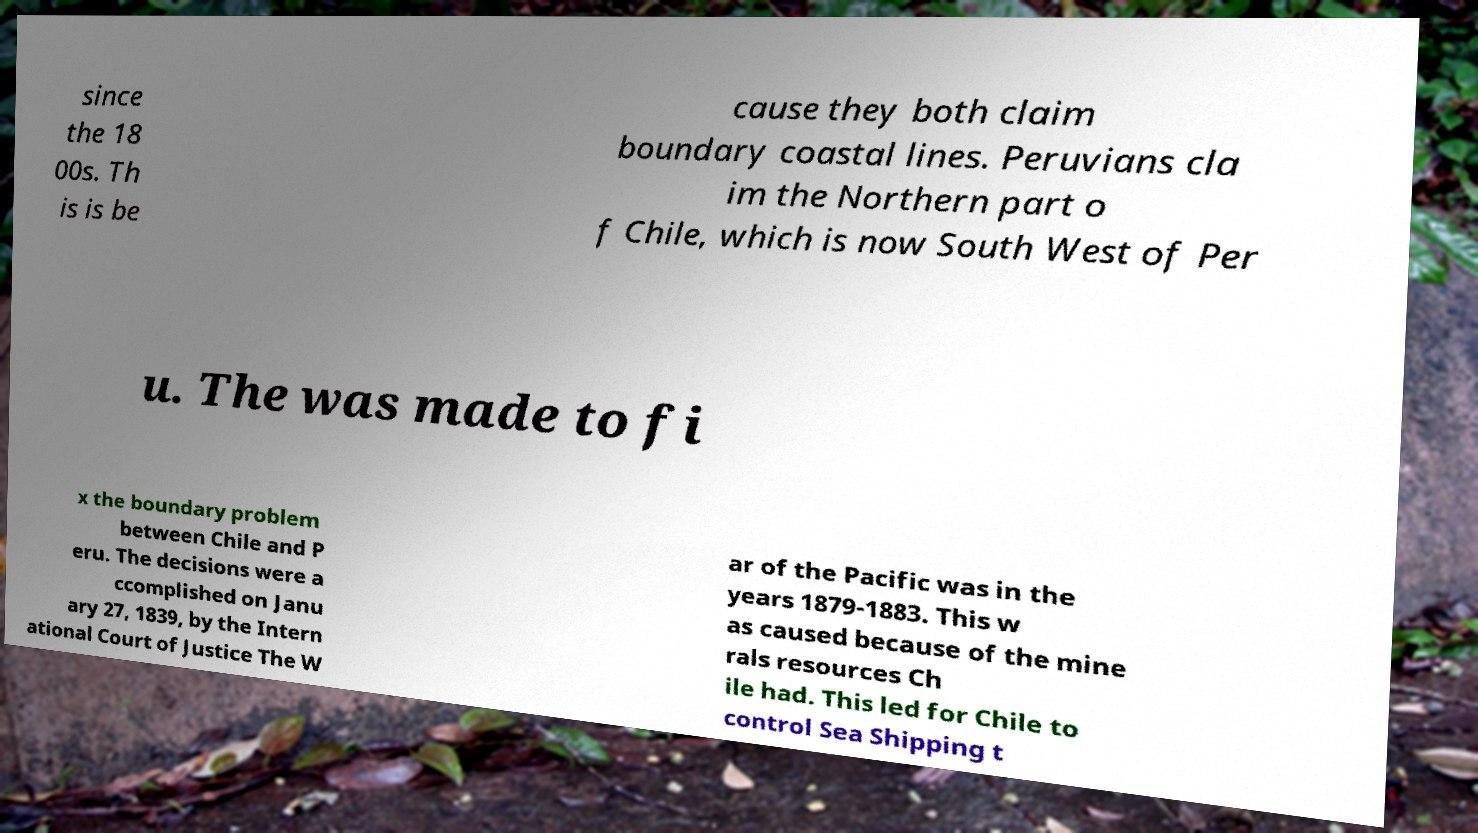For documentation purposes, I need the text within this image transcribed. Could you provide that? since the 18 00s. Th is is be cause they both claim boundary coastal lines. Peruvians cla im the Northern part o f Chile, which is now South West of Per u. The was made to fi x the boundary problem between Chile and P eru. The decisions were a ccomplished on Janu ary 27, 1839, by the Intern ational Court of Justice The W ar of the Pacific was in the years 1879-1883. This w as caused because of the mine rals resources Ch ile had. This led for Chile to control Sea Shipping t 